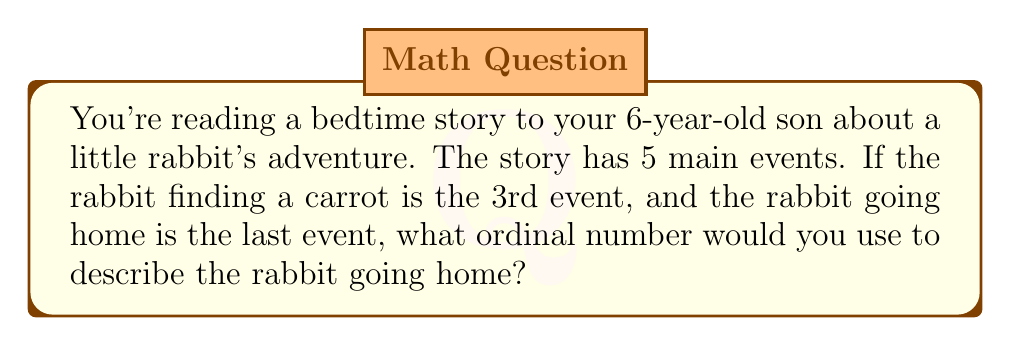Can you solve this math problem? Let's break this down step-by-step:

1. We know there are 5 main events in the story.
2. We can represent these events using ordinal numbers:
   $1^{st}, 2^{nd}, 3^{rd}, 4^{th}, 5^{th}$

3. We're told that the rabbit finding a carrot is the $3^{rd}$ event.
4. We're also told that the rabbit going home is the last event.
5. In a sequence of 5 events, the last event would be the $5^{th}$ event.

Therefore, the rabbit going home, being the last of 5 events, would be described using the ordinal number $5^{th}$.
Answer: $5^{th}$ 